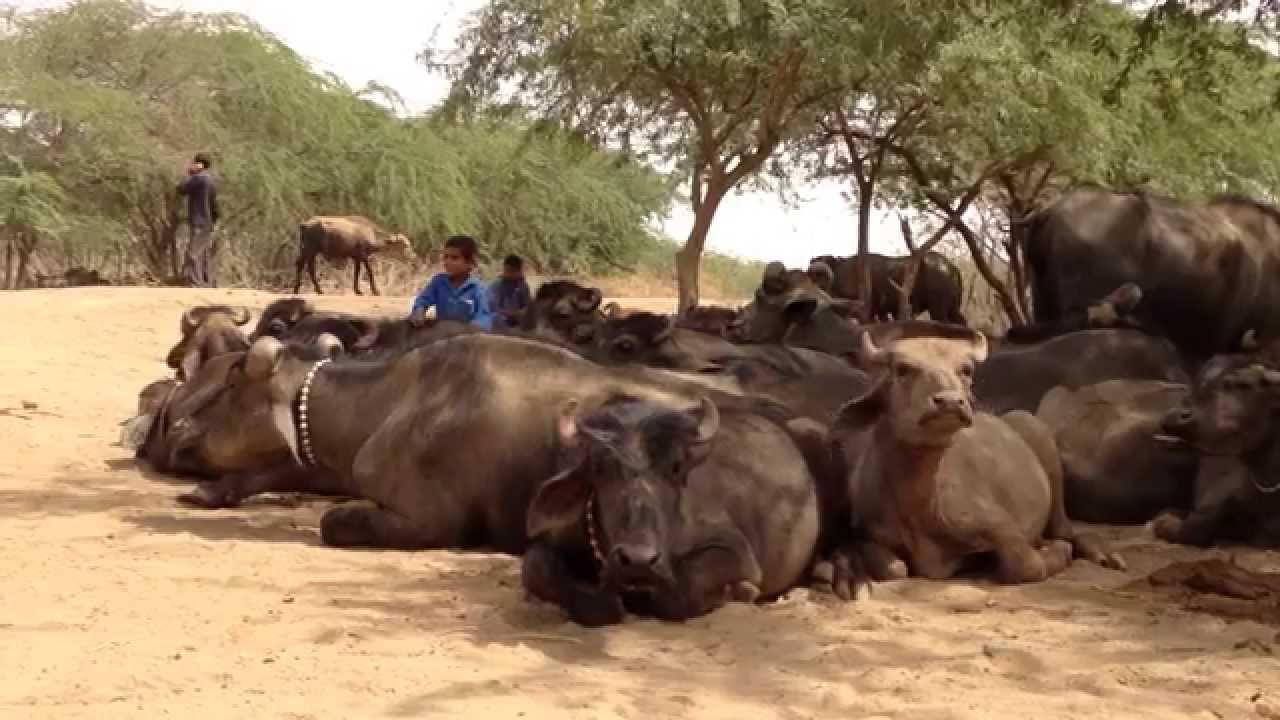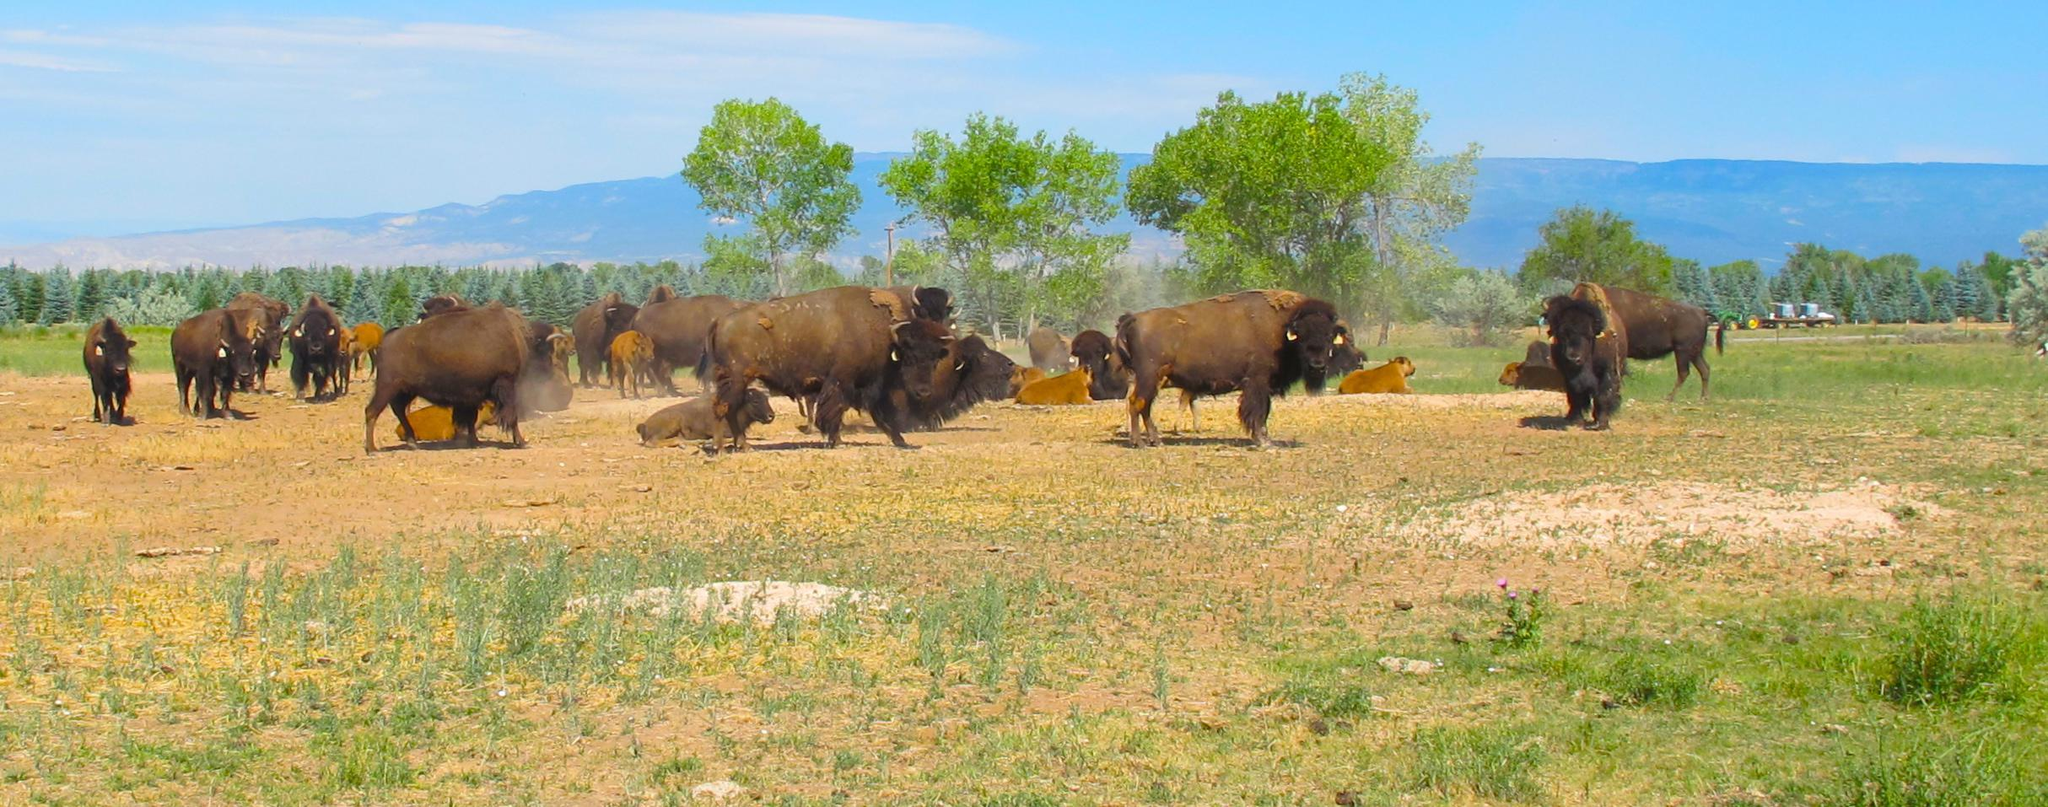The first image is the image on the left, the second image is the image on the right. Evaluate the accuracy of this statement regarding the images: "There is at one man with a blue shirt in the middle of at least 10 horned oxes.". Is it true? Answer yes or no. Yes. The first image is the image on the left, the second image is the image on the right. Analyze the images presented: Is the assertion "A person wearing bright blue is in the middle of a large group of oxen in one image." valid? Answer yes or no. Yes. 